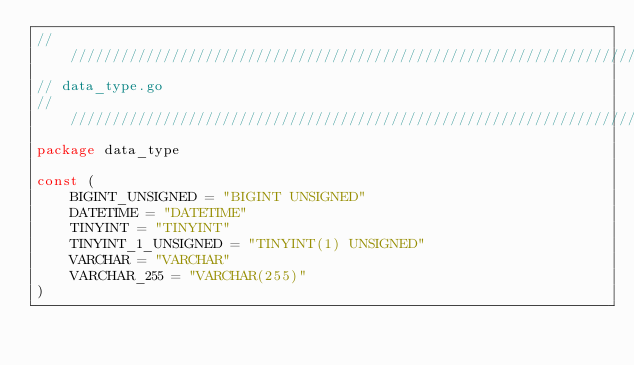<code> <loc_0><loc_0><loc_500><loc_500><_Go_>//////////////////////////////////////////////////////////////////////
// data_type.go
//////////////////////////////////////////////////////////////////////
package data_type

const (
    BIGINT_UNSIGNED = "BIGINT UNSIGNED"
    DATETIME = "DATETIME"
    TINYINT = "TINYINT"
    TINYINT_1_UNSIGNED = "TINYINT(1) UNSIGNED"
    VARCHAR = "VARCHAR"
    VARCHAR_255 = "VARCHAR(255)"
)
</code> 